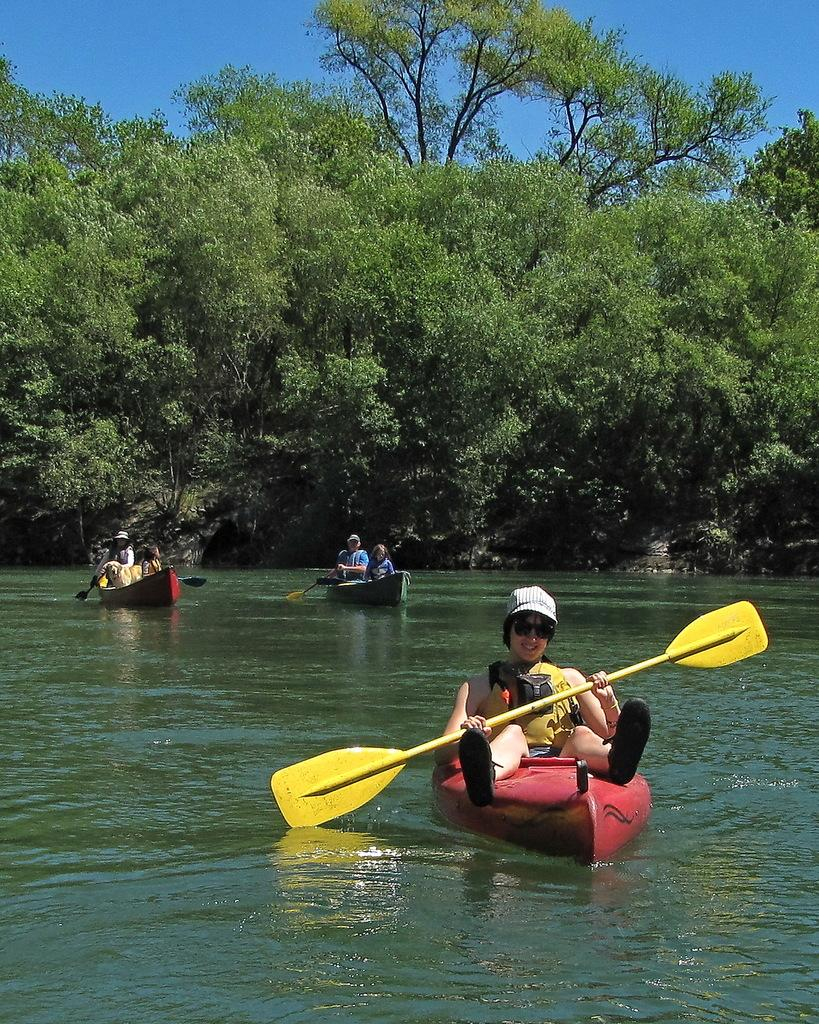What is floating on the water in the image? There are boats on the surface of the water in the image. Are there any people on the boats? Yes, people are present on the boats. What can be seen in the background of the image? There are trees visible in the image. What is visible at the top of the image? The sky is visible at the top of the image. Where is the cobweb located in the image? There is no cobweb present in the image. Can you describe the tiger's behavior in the image? There is no tiger present in the image. 